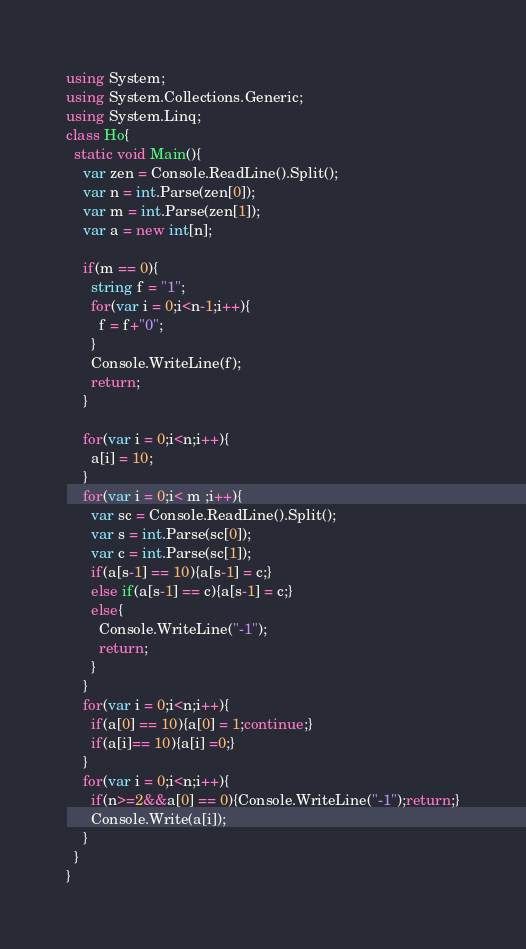Convert code to text. <code><loc_0><loc_0><loc_500><loc_500><_C#_>using System;
using System.Collections.Generic;
using System.Linq;
class Ho{
  static void Main(){
    var zen = Console.ReadLine().Split();
    var n = int.Parse(zen[0]);
    var m = int.Parse(zen[1]);
    var a = new int[n];
    
    if(m == 0){
      string f = "1";
      for(var i = 0;i<n-1;i++){
        f = f+"0";
      }
      Console.WriteLine(f);
      return;
    }
    
    for(var i = 0;i<n;i++){
      a[i] = 10;
    }
    for(var i = 0;i< m ;i++){
      var sc = Console.ReadLine().Split();
      var s = int.Parse(sc[0]);
      var c = int.Parse(sc[1]);
      if(a[s-1] == 10){a[s-1] = c;}
      else if(a[s-1] == c){a[s-1] = c;}
      else{
        Console.WriteLine("-1");
        return;
      }  
    }
    for(var i = 0;i<n;i++){
      if(a[0] == 10){a[0] = 1;continue;}
      if(a[i]== 10){a[i] =0;}
    }
    for(var i = 0;i<n;i++){
      if(n>=2&&a[0] == 0){Console.WriteLine("-1");return;}
      Console.Write(a[i]);
    }
  }
}</code> 